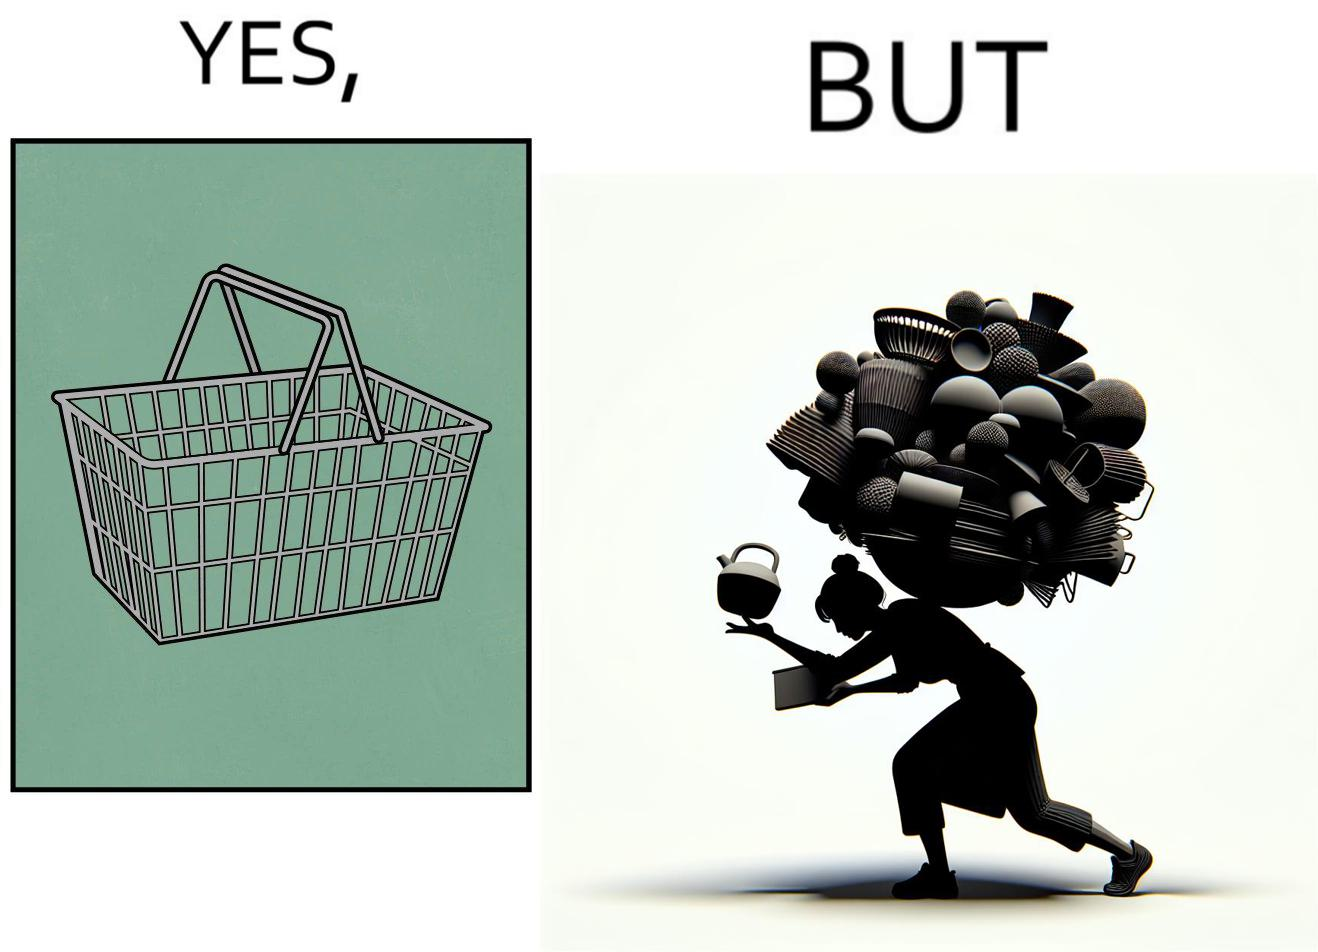Describe the content of this image. The image is ironic, because even when there are steel frame baskets are available at the supermarkets people prefer carrying the items in hand 